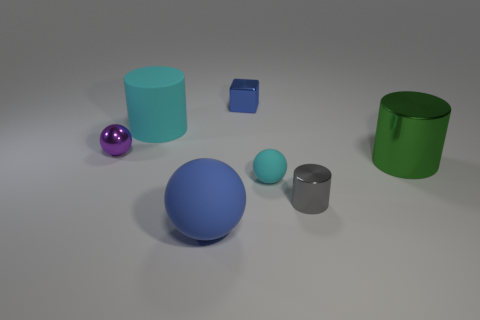Is there anything else that has the same shape as the small blue object?
Offer a very short reply. No. How many objects are cylinders to the left of the gray metallic object or objects in front of the big rubber cylinder?
Offer a terse response. 6. There is a small metallic thing that is the same shape as the big blue rubber object; what color is it?
Make the answer very short. Purple. How many large things are the same color as the rubber cylinder?
Your answer should be very brief. 0. Does the large matte cylinder have the same color as the tiny rubber sphere?
Offer a very short reply. Yes. How many things are either cyan rubber objects left of the big blue rubber thing or big brown metal balls?
Provide a succinct answer. 1. What color is the sphere that is on the right side of the blue thing in front of the cyan matte thing in front of the purple object?
Your response must be concise. Cyan. The other sphere that is made of the same material as the big blue sphere is what color?
Your response must be concise. Cyan. How many other things are the same material as the small purple object?
Provide a succinct answer. 3. Do the blue object that is in front of the gray cylinder and the tiny purple object have the same size?
Offer a very short reply. No. 